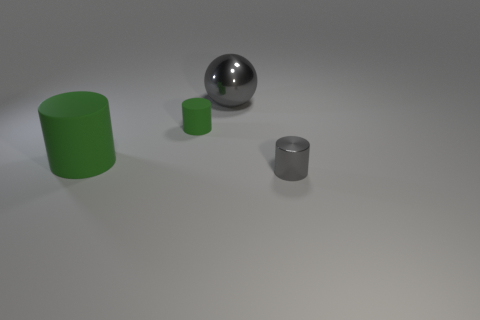There is a small green thing; is its shape the same as the thing to the left of the small green cylinder?
Your answer should be very brief. Yes. Is the number of gray things that are in front of the tiny green matte cylinder greater than the number of big blue balls?
Offer a terse response. Yes. Is the number of green things to the left of the gray shiny cylinder less than the number of cylinders?
Ensure brevity in your answer.  Yes. What number of objects have the same color as the large sphere?
Give a very brief answer. 1. There is a object that is right of the small matte cylinder and in front of the small green rubber object; what is its material?
Your response must be concise. Metal. There is a shiny object left of the tiny metallic cylinder; is it the same color as the small cylinder that is on the left side of the shiny cylinder?
Make the answer very short. No. What number of green things are big matte objects or metallic cylinders?
Ensure brevity in your answer.  1. Is the number of big green rubber objects that are left of the large green object less than the number of tiny objects that are behind the tiny gray cylinder?
Keep it short and to the point. Yes. Is there a gray metallic object that has the same size as the metal ball?
Your answer should be compact. No. There is a object on the right side of the gray sphere; is its size the same as the big green cylinder?
Your answer should be compact. No. 